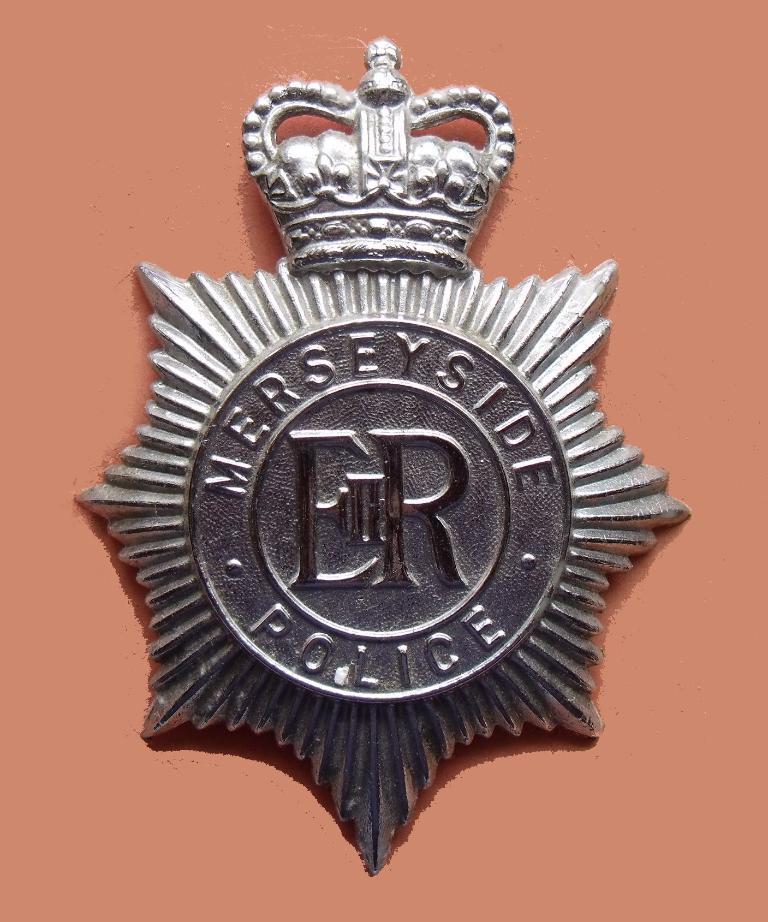In one or two sentences, can you explain what this image depicts? This is a picture of a police badge on the object. 